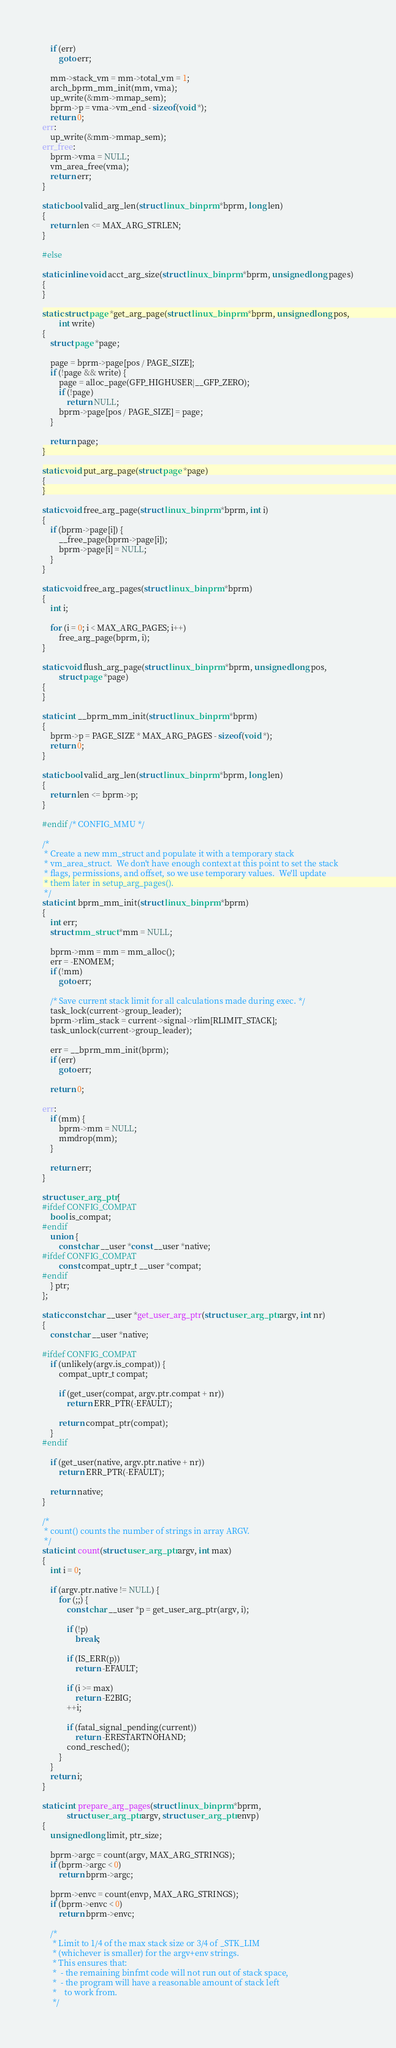<code> <loc_0><loc_0><loc_500><loc_500><_C_>	if (err)
		goto err;

	mm->stack_vm = mm->total_vm = 1;
	arch_bprm_mm_init(mm, vma);
	up_write(&mm->mmap_sem);
	bprm->p = vma->vm_end - sizeof(void *);
	return 0;
err:
	up_write(&mm->mmap_sem);
err_free:
	bprm->vma = NULL;
	vm_area_free(vma);
	return err;
}

static bool valid_arg_len(struct linux_binprm *bprm, long len)
{
	return len <= MAX_ARG_STRLEN;
}

#else

static inline void acct_arg_size(struct linux_binprm *bprm, unsigned long pages)
{
}

static struct page *get_arg_page(struct linux_binprm *bprm, unsigned long pos,
		int write)
{
	struct page *page;

	page = bprm->page[pos / PAGE_SIZE];
	if (!page && write) {
		page = alloc_page(GFP_HIGHUSER|__GFP_ZERO);
		if (!page)
			return NULL;
		bprm->page[pos / PAGE_SIZE] = page;
	}

	return page;
}

static void put_arg_page(struct page *page)
{
}

static void free_arg_page(struct linux_binprm *bprm, int i)
{
	if (bprm->page[i]) {
		__free_page(bprm->page[i]);
		bprm->page[i] = NULL;
	}
}

static void free_arg_pages(struct linux_binprm *bprm)
{
	int i;

	for (i = 0; i < MAX_ARG_PAGES; i++)
		free_arg_page(bprm, i);
}

static void flush_arg_page(struct linux_binprm *bprm, unsigned long pos,
		struct page *page)
{
}

static int __bprm_mm_init(struct linux_binprm *bprm)
{
	bprm->p = PAGE_SIZE * MAX_ARG_PAGES - sizeof(void *);
	return 0;
}

static bool valid_arg_len(struct linux_binprm *bprm, long len)
{
	return len <= bprm->p;
}

#endif /* CONFIG_MMU */

/*
 * Create a new mm_struct and populate it with a temporary stack
 * vm_area_struct.  We don't have enough context at this point to set the stack
 * flags, permissions, and offset, so we use temporary values.  We'll update
 * them later in setup_arg_pages().
 */
static int bprm_mm_init(struct linux_binprm *bprm)
{
	int err;
	struct mm_struct *mm = NULL;

	bprm->mm = mm = mm_alloc();
	err = -ENOMEM;
	if (!mm)
		goto err;

	/* Save current stack limit for all calculations made during exec. */
	task_lock(current->group_leader);
	bprm->rlim_stack = current->signal->rlim[RLIMIT_STACK];
	task_unlock(current->group_leader);

	err = __bprm_mm_init(bprm);
	if (err)
		goto err;

	return 0;

err:
	if (mm) {
		bprm->mm = NULL;
		mmdrop(mm);
	}

	return err;
}

struct user_arg_ptr {
#ifdef CONFIG_COMPAT
	bool is_compat;
#endif
	union {
		const char __user *const __user *native;
#ifdef CONFIG_COMPAT
		const compat_uptr_t __user *compat;
#endif
	} ptr;
};

static const char __user *get_user_arg_ptr(struct user_arg_ptr argv, int nr)
{
	const char __user *native;

#ifdef CONFIG_COMPAT
	if (unlikely(argv.is_compat)) {
		compat_uptr_t compat;

		if (get_user(compat, argv.ptr.compat + nr))
			return ERR_PTR(-EFAULT);

		return compat_ptr(compat);
	}
#endif

	if (get_user(native, argv.ptr.native + nr))
		return ERR_PTR(-EFAULT);

	return native;
}

/*
 * count() counts the number of strings in array ARGV.
 */
static int count(struct user_arg_ptr argv, int max)
{
	int i = 0;

	if (argv.ptr.native != NULL) {
		for (;;) {
			const char __user *p = get_user_arg_ptr(argv, i);

			if (!p)
				break;

			if (IS_ERR(p))
				return -EFAULT;

			if (i >= max)
				return -E2BIG;
			++i;

			if (fatal_signal_pending(current))
				return -ERESTARTNOHAND;
			cond_resched();
		}
	}
	return i;
}

static int prepare_arg_pages(struct linux_binprm *bprm,
			struct user_arg_ptr argv, struct user_arg_ptr envp)
{
	unsigned long limit, ptr_size;

	bprm->argc = count(argv, MAX_ARG_STRINGS);
	if (bprm->argc < 0)
		return bprm->argc;

	bprm->envc = count(envp, MAX_ARG_STRINGS);
	if (bprm->envc < 0)
		return bprm->envc;

	/*
	 * Limit to 1/4 of the max stack size or 3/4 of _STK_LIM
	 * (whichever is smaller) for the argv+env strings.
	 * This ensures that:
	 *  - the remaining binfmt code will not run out of stack space,
	 *  - the program will have a reasonable amount of stack left
	 *    to work from.
	 */</code> 